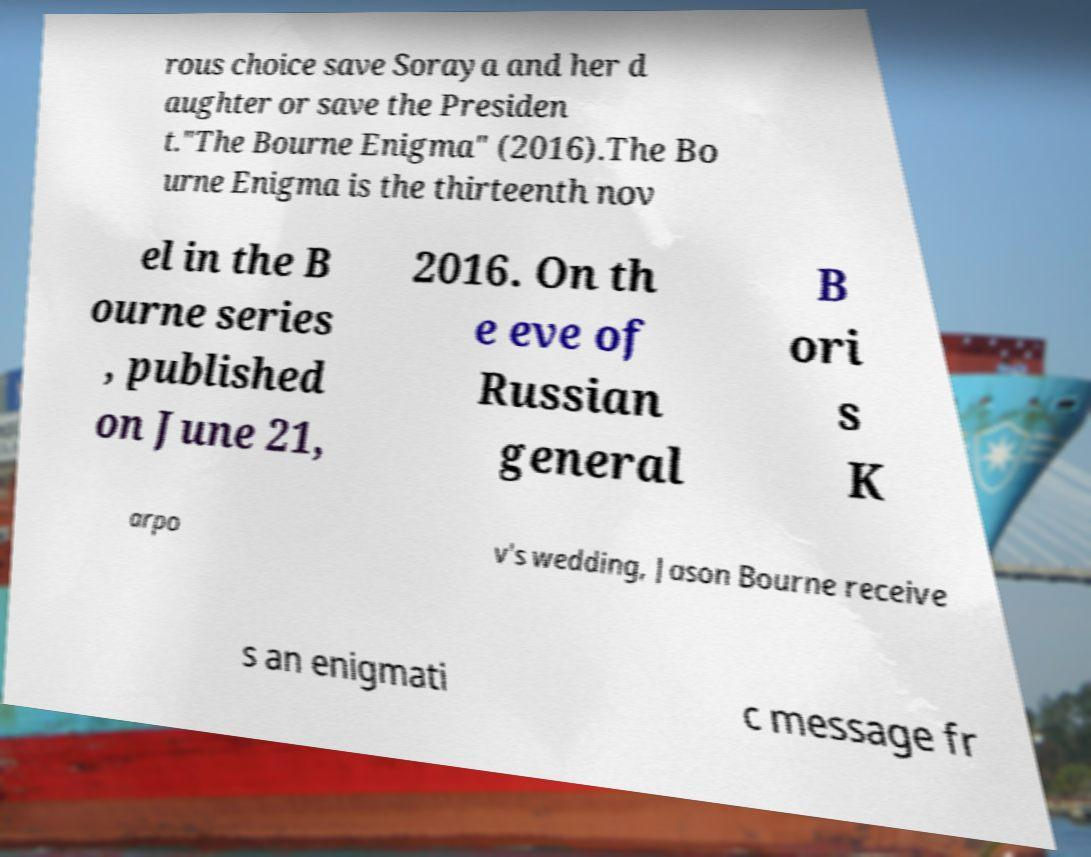Please identify and transcribe the text found in this image. rous choice save Soraya and her d aughter or save the Presiden t."The Bourne Enigma" (2016).The Bo urne Enigma is the thirteenth nov el in the B ourne series , published on June 21, 2016. On th e eve of Russian general B ori s K arpo v's wedding, Jason Bourne receive s an enigmati c message fr 